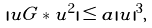Convert formula to latex. <formula><loc_0><loc_0><loc_500><loc_500>| u G * u ^ { 2 } | \leq a | u | ^ { 3 } ,</formula> 